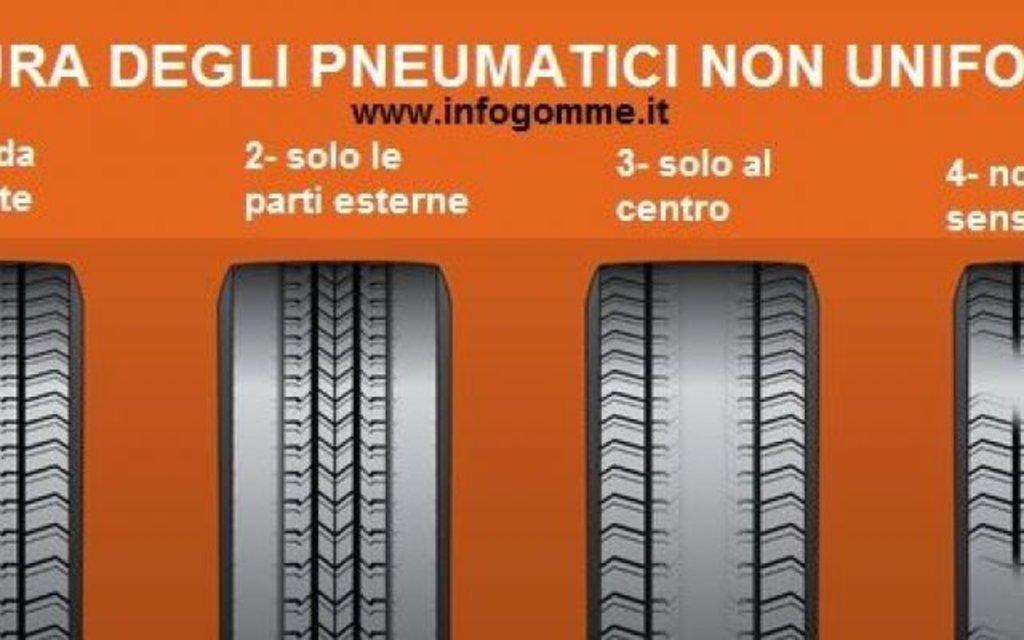How would you summarize this image in a sentence or two? This is a poster with orange background. On that something is written. Also there are tires. 